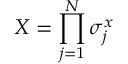Convert formula to latex. <formula><loc_0><loc_0><loc_500><loc_500>X = \prod _ { j = 1 } ^ { N } \sigma _ { j } ^ { x }</formula> 